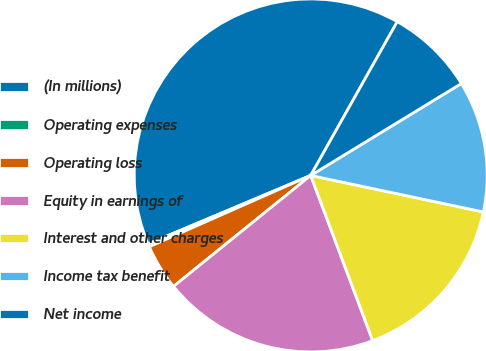Convert chart. <chart><loc_0><loc_0><loc_500><loc_500><pie_chart><fcel>(In millions)<fcel>Operating expenses<fcel>Operating loss<fcel>Equity in earnings of<fcel>Interest and other charges<fcel>Income tax benefit<fcel>Net income<nl><fcel>39.5%<fcel>0.28%<fcel>4.2%<fcel>19.89%<fcel>15.97%<fcel>12.04%<fcel>8.12%<nl></chart> 